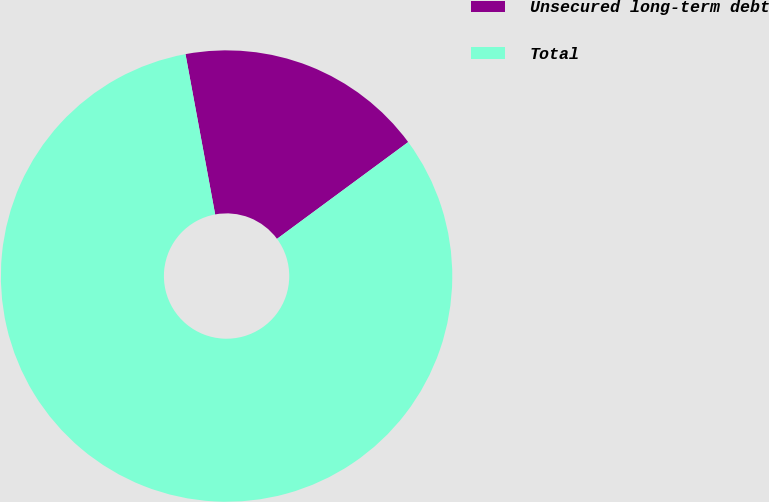<chart> <loc_0><loc_0><loc_500><loc_500><pie_chart><fcel>Unsecured long-term debt<fcel>Total<nl><fcel>17.8%<fcel>82.2%<nl></chart> 